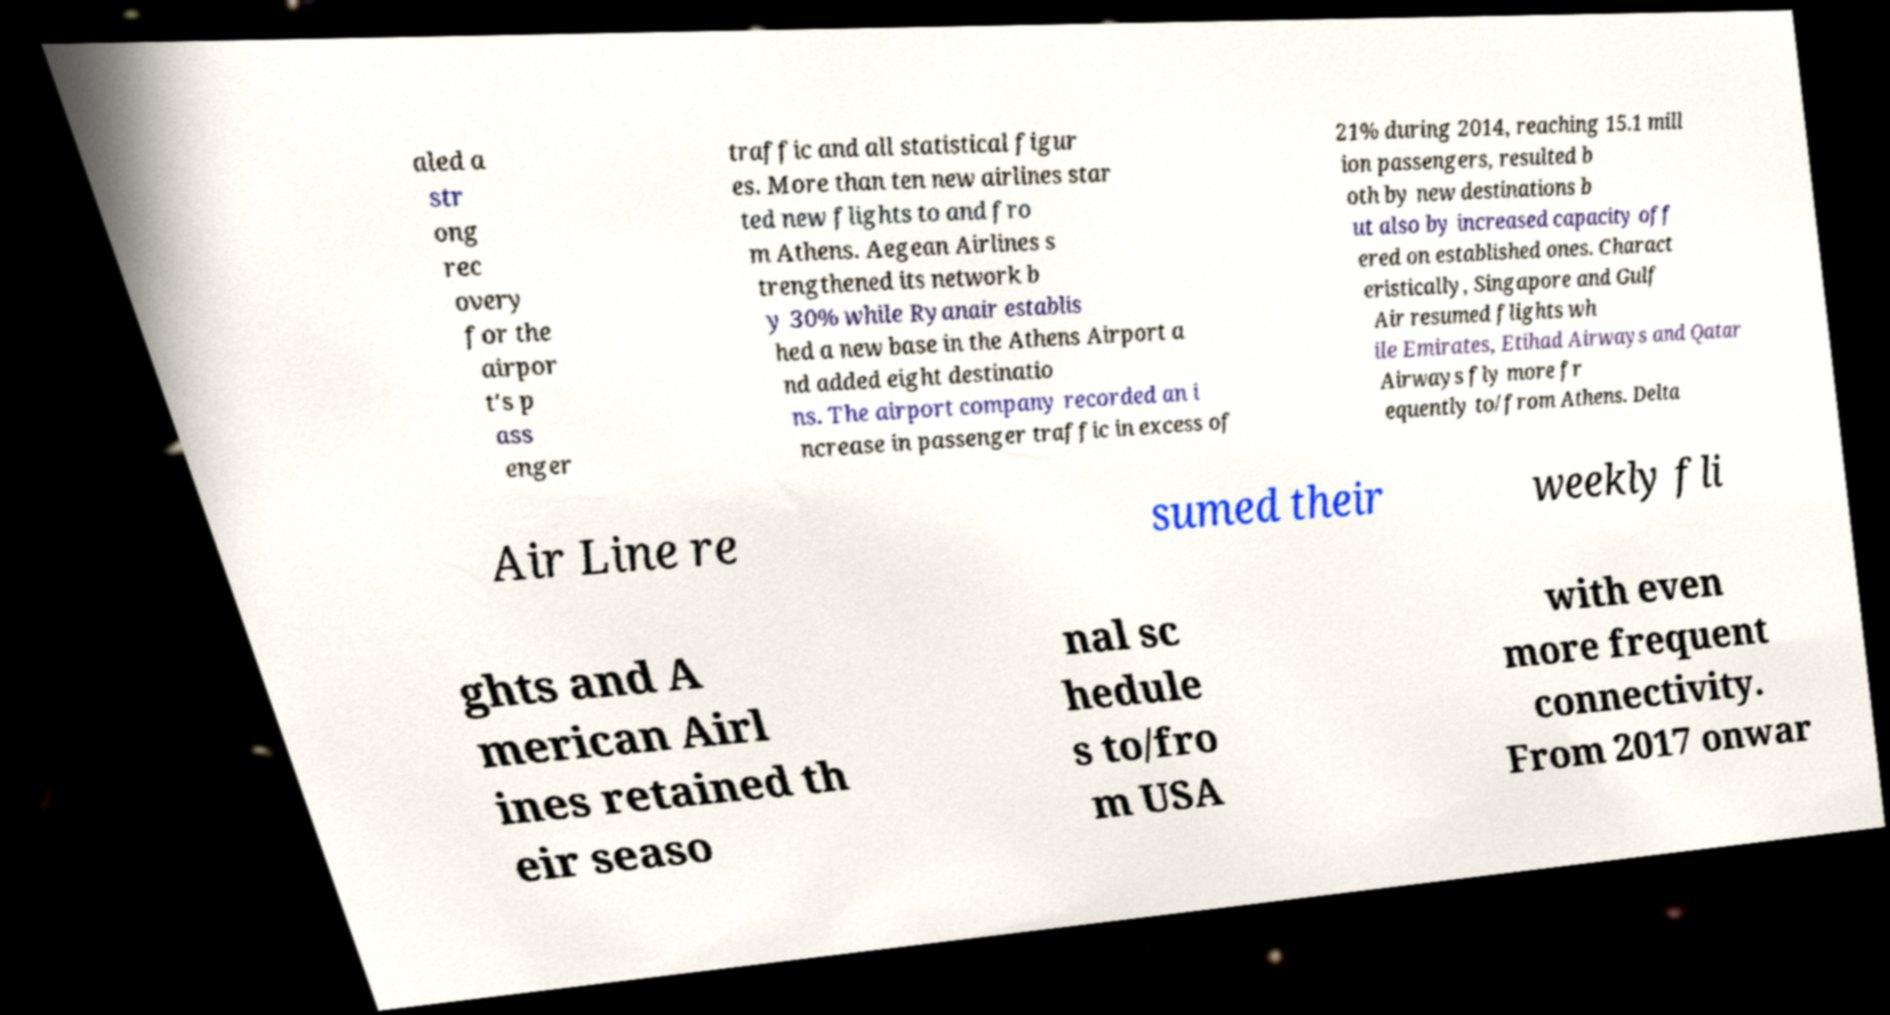What messages or text are displayed in this image? I need them in a readable, typed format. aled a str ong rec overy for the airpor t's p ass enger traffic and all statistical figur es. More than ten new airlines star ted new flights to and fro m Athens. Aegean Airlines s trengthened its network b y 30% while Ryanair establis hed a new base in the Athens Airport a nd added eight destinatio ns. The airport company recorded an i ncrease in passenger traffic in excess of 21% during 2014, reaching 15.1 mill ion passengers, resulted b oth by new destinations b ut also by increased capacity off ered on established ones. Charact eristically, Singapore and Gulf Air resumed flights wh ile Emirates, Etihad Airways and Qatar Airways fly more fr equently to/from Athens. Delta Air Line re sumed their weekly fli ghts and A merican Airl ines retained th eir seaso nal sc hedule s to/fro m USA with even more frequent connectivity. From 2017 onwar 